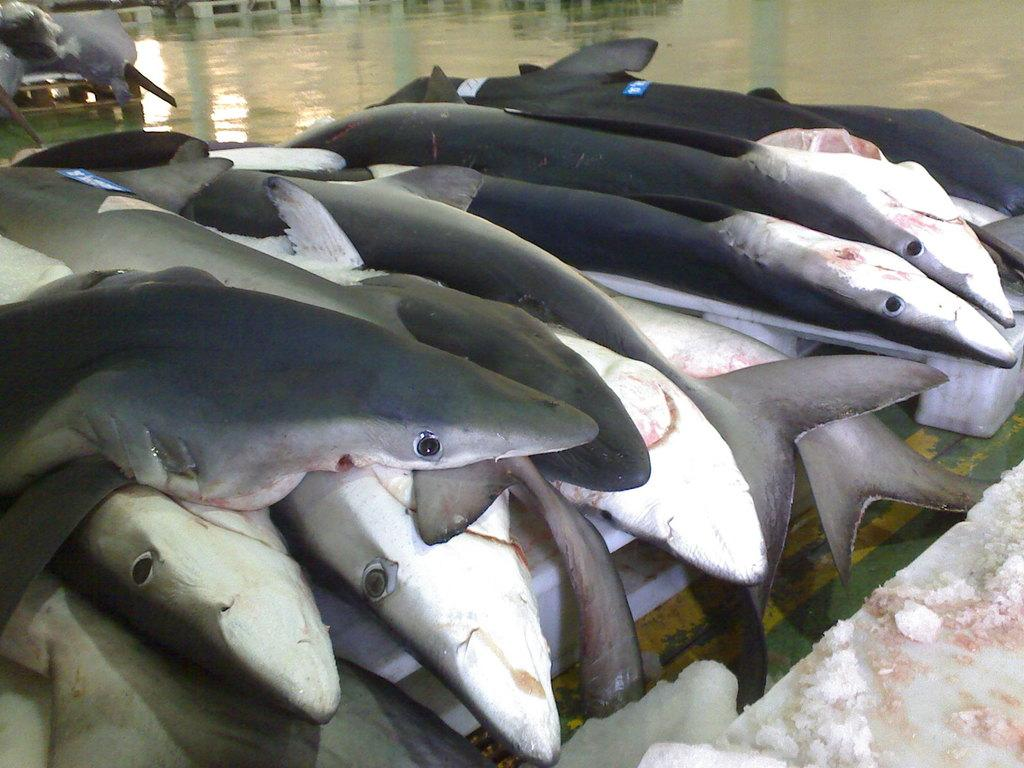What is the main subject of the image? The main subject of the image is dead fishes. Where are the dead fishes located in the image? The dead fishes are kept on a table in the image. How many cherries are on the table with the dead fishes? There is no mention of cherries in the image, so we cannot determine if any are present. 